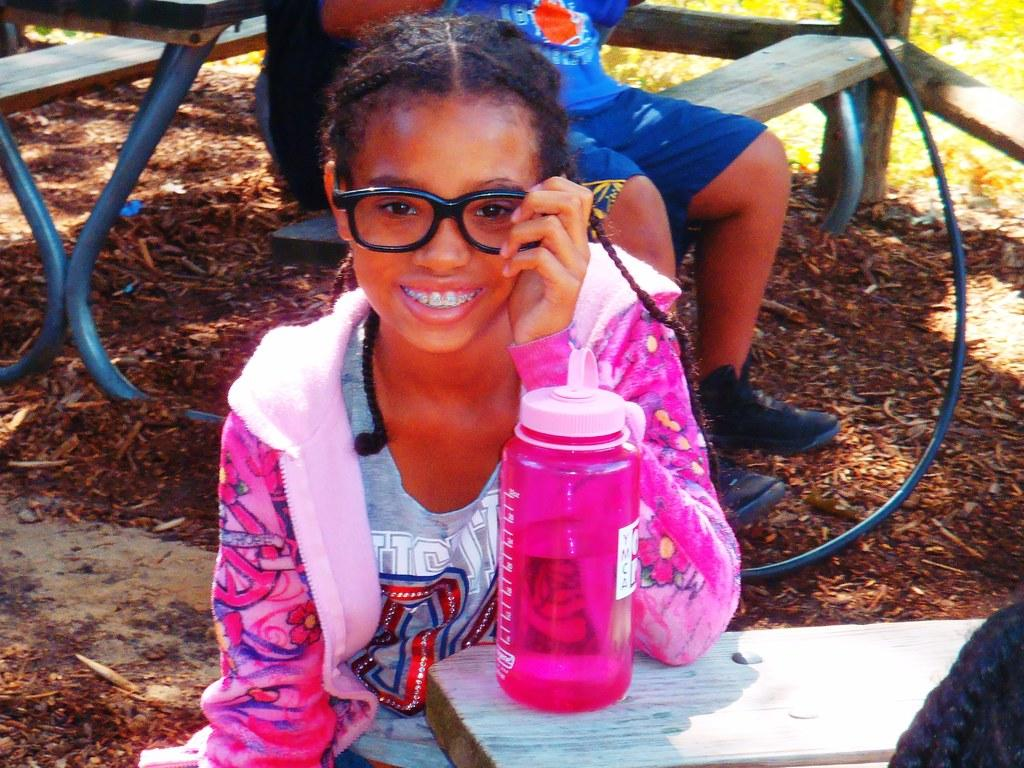What is the girl in the image doing? The girl is sitting and smiling in the image. Can you describe the other person in the image? There is another person sitting on a bench in the background. What object can be seen on a table in the image? There is a bottle on a table in the image. What type of vegetation is present at the bottom of the image? Leaves are present at the bottom of the image. What is the argument about between the woman and the geese in the image? There is no woman or geese present in the image, so there cannot be an argument between them. 